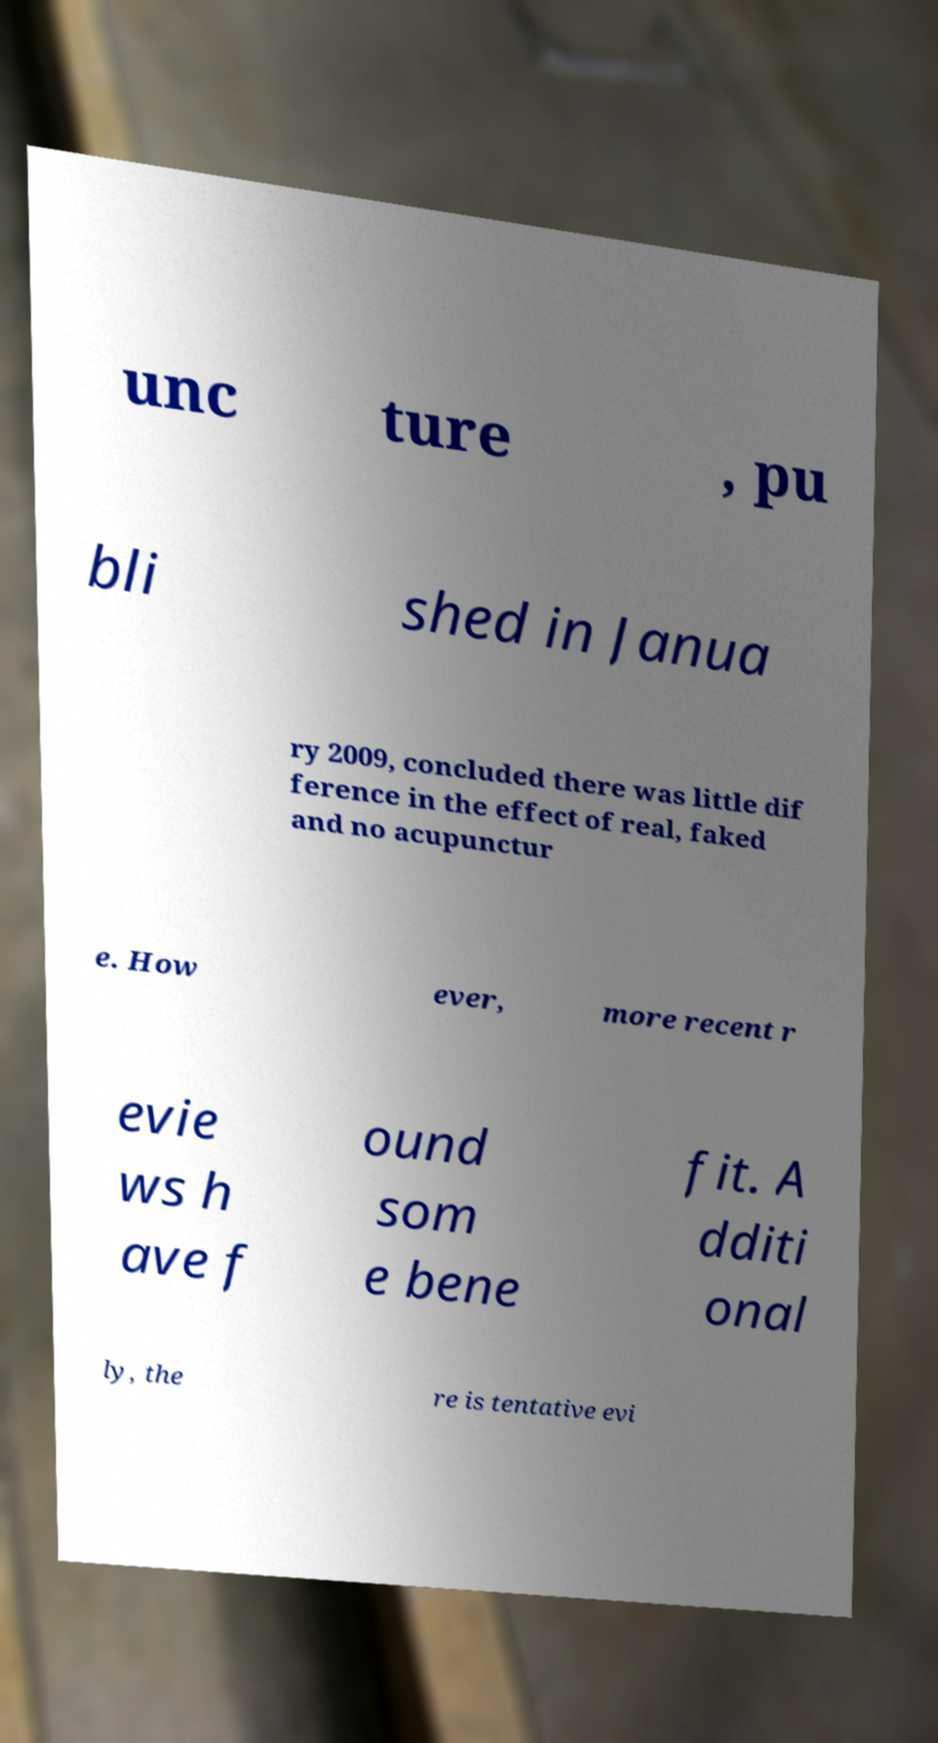Could you extract and type out the text from this image? unc ture , pu bli shed in Janua ry 2009, concluded there was little dif ference in the effect of real, faked and no acupunctur e. How ever, more recent r evie ws h ave f ound som e bene fit. A dditi onal ly, the re is tentative evi 